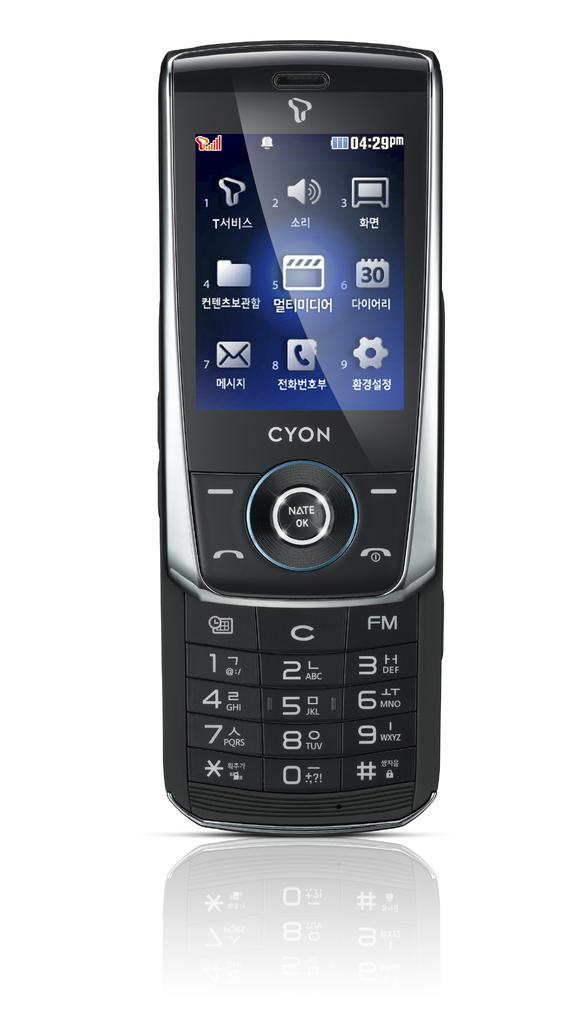<image>
Provide a brief description of the given image. The front side to a syon branded cellphone with icons for several functions written in chinese. 